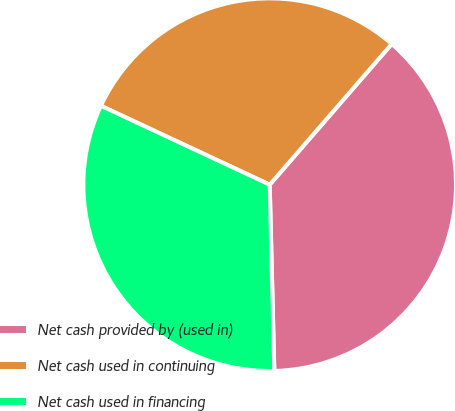Convert chart. <chart><loc_0><loc_0><loc_500><loc_500><pie_chart><fcel>Net cash provided by (used in)<fcel>Net cash used in continuing<fcel>Net cash used in financing<nl><fcel>38.24%<fcel>29.41%<fcel>32.35%<nl></chart> 